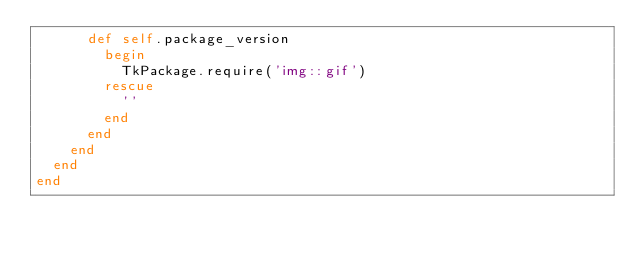<code> <loc_0><loc_0><loc_500><loc_500><_Ruby_>      def self.package_version
        begin
          TkPackage.require('img::gif')
        rescue
          ''
        end
      end
    end
  end
end
</code> 